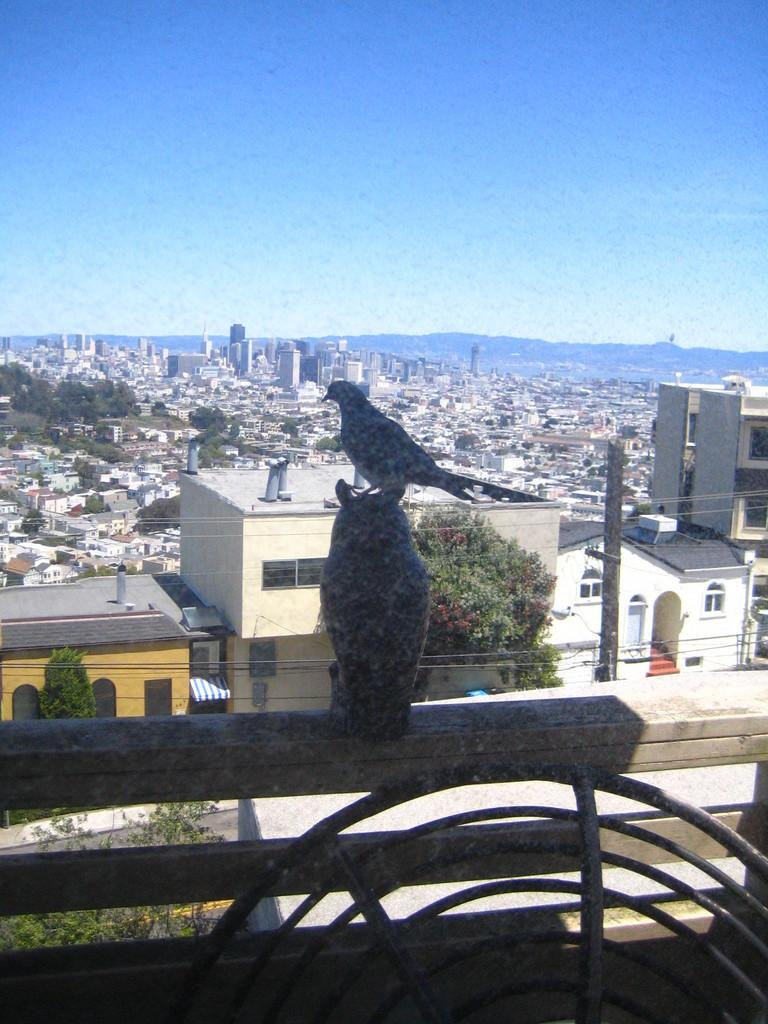What is located on the railing in the image? There is a statue on the railing in the image. What objects can be seen in the image besides the statue? There are rods visible in the image. What can be seen in the background of the image? There are buildings, trees, a pole, and the sky visible in the background of the image. What type of news can be seen on the statue in the image? There is no news present on the statue in the image. How many eggs are visible on the pole in the image? There are no eggs present on the pole in the image. 